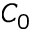<formula> <loc_0><loc_0><loc_500><loc_500>C _ { 0 }</formula> 